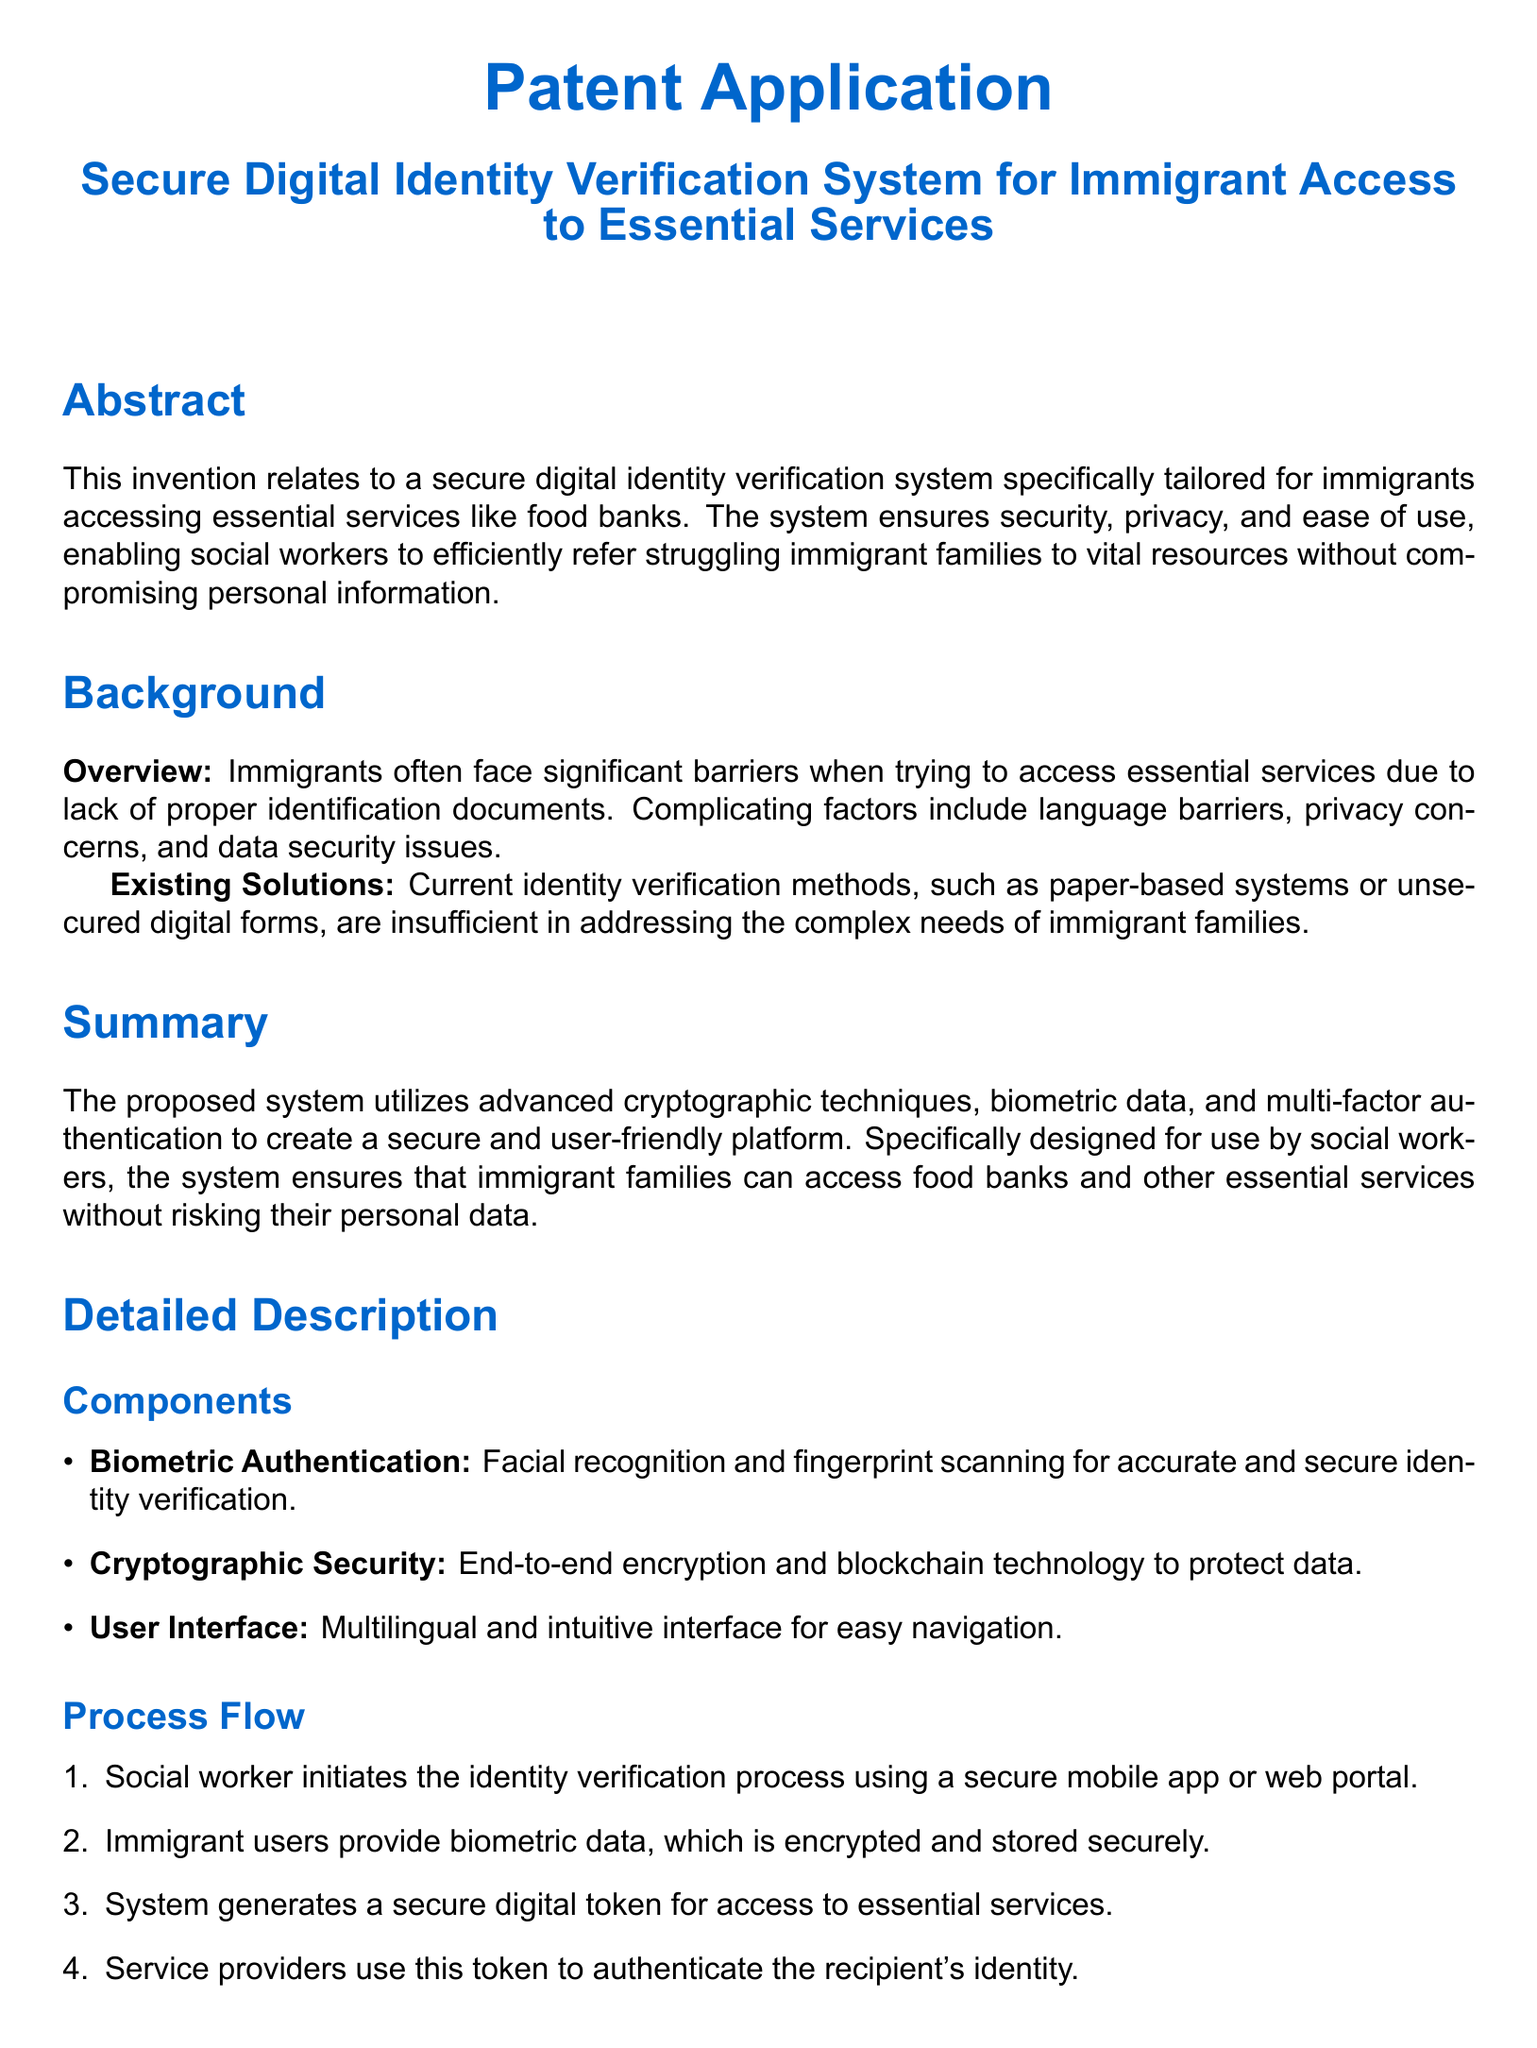What is the title of the patent application? The title of the patent application is provided in the document's heading.
Answer: Secure Digital Identity Verification System for Immigrant Access to Essential Services What are the two biometric authentication methods mentioned? The document lists the specific biometric data types used in the system.
Answer: Facial recognition and fingerprint scanning What encryption technique is used in the system? The document mentions specific technologies to secure data within the system.
Answer: End-to-end encryption What is the main advantage related to personal data protection? The advantages section discusses security features of the system.
Answer: Enhanced protection of personal data Who initiates the identity verification process? The document specifies the role of individuals initiating the process in the flow description.
Answer: Social worker How many claims are made in the patent application? The claims section enumerates the specific claims made by the invention.
Answer: Five claims What type of interface is designed for user navigation? The document describes the user interface designed for ease of use.
Answer: Multilingual and intuitive interface What problem does the invention specifically address for immigrants? The background section discusses the primary challenges faced by immigrant families.
Answer: Lack of proper identification documents 